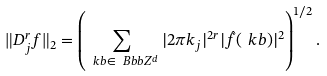Convert formula to latex. <formula><loc_0><loc_0><loc_500><loc_500>\| D _ { j } ^ { r } f \| _ { 2 } = \left ( \sum _ { \ k b \in \ B b b Z ^ { d } } | 2 \pi k _ { j } | ^ { 2 r } | \hat { f } ( \ k b ) | ^ { 2 } \right ) ^ { 1 / 2 } .</formula> 